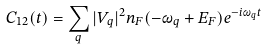<formula> <loc_0><loc_0><loc_500><loc_500>C _ { 1 2 } ( t ) = \sum _ { q } | V _ { q } | ^ { 2 } n _ { F } ( - \omega _ { q } + E _ { F } ) e ^ { - i \omega _ { q } t }</formula> 